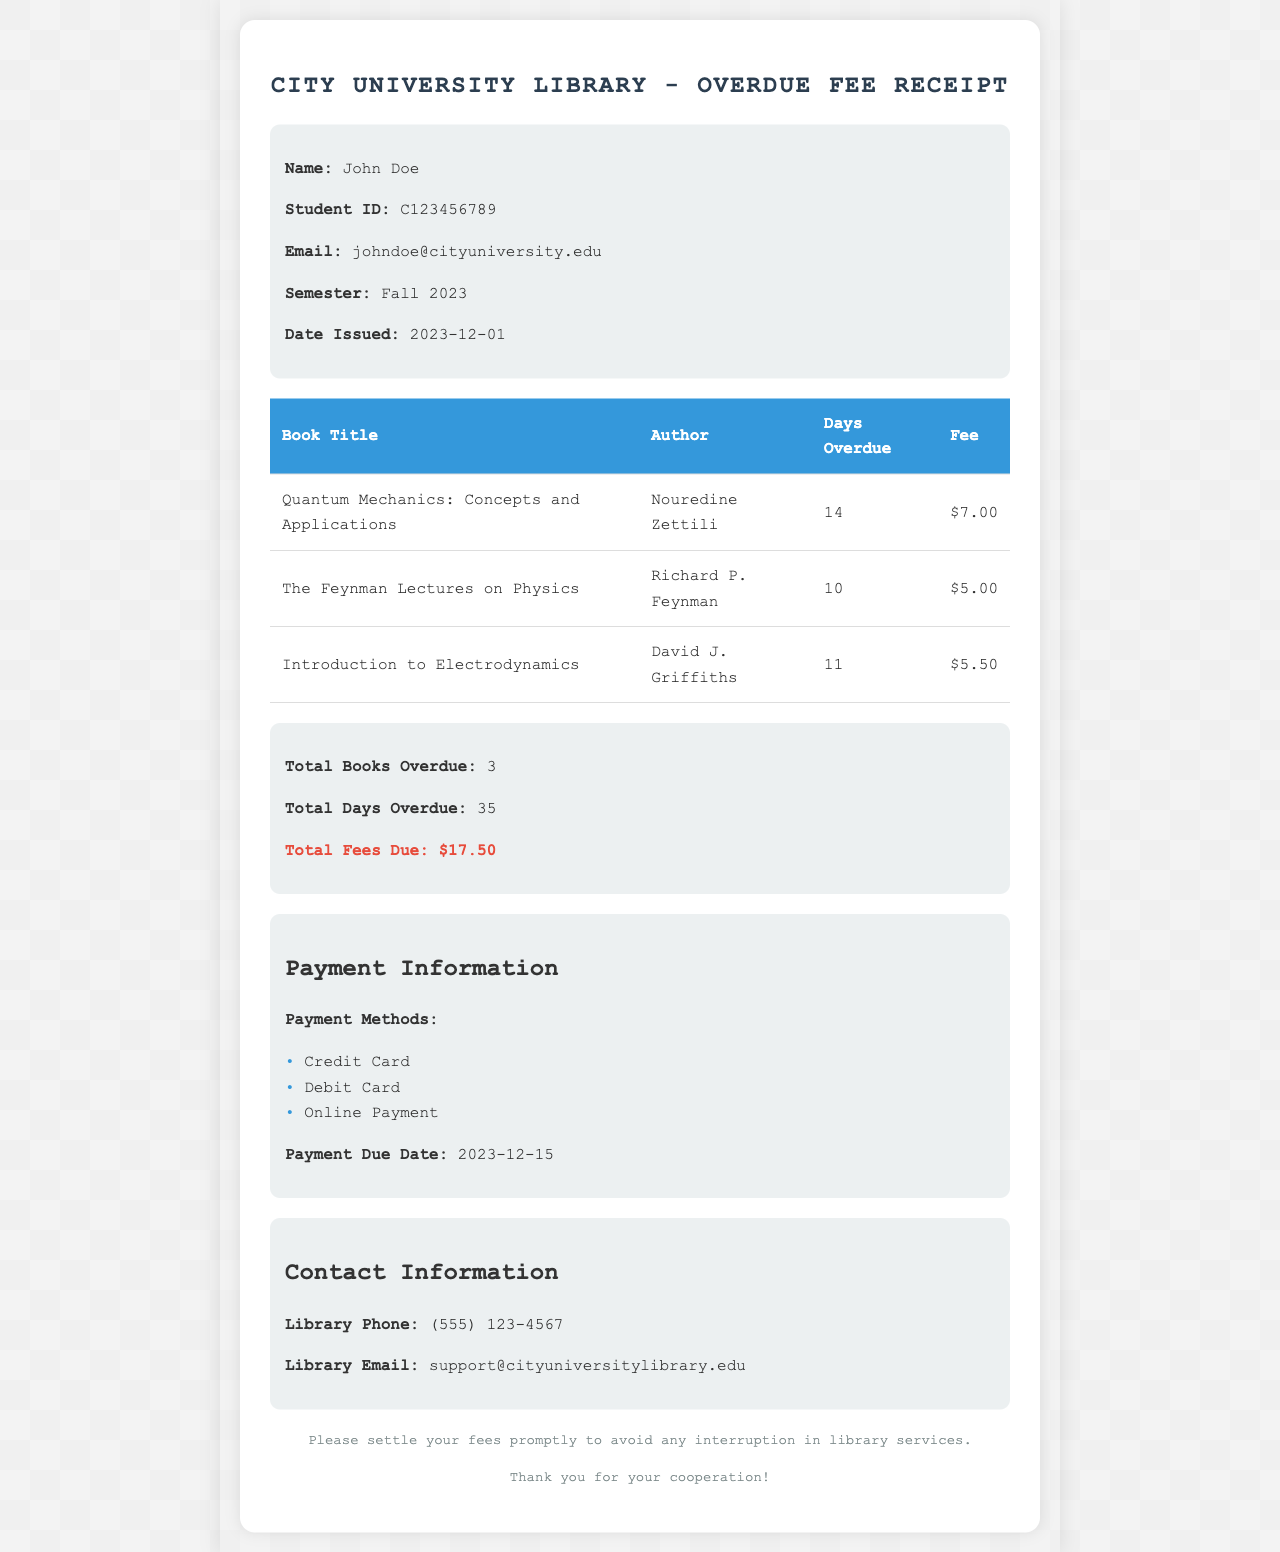What is the student's name? The student's name is listed in the document under the student info section.
Answer: John Doe What is the total number of overdue books? The total number of overdue books is explicitly stated in the summary section of the document.
Answer: 3 What is the total fees due? The total fees due is presented in the summary section as well.
Answer: $17.50 How many days was the "Quantum Mechanics: Concepts and Applications" book overdue? The number of overdue days for this specific book is detailed in the table.
Answer: 14 What is the payment due date? The payment due date can be found in the payment information section of the document.
Answer: 2023-12-15 Which book accrued the highest fee? The fees for each book can be compared in the table to determine which is highest.
Answer: Quantum Mechanics: Concepts and Applications What is the author's name of "The Feynman Lectures on Physics"? The author's name is listed alongside the book title in the table.
Answer: Richard P. Feynman What are the accepted payment methods? The payment methods are listed in the payment information section.
Answer: Credit Card, Debit Card, Online Payment How many days was the "Introduction to Electrodynamics" book overdue? The number of overdue days for this book is outlined in the table provided.
Answer: 11 